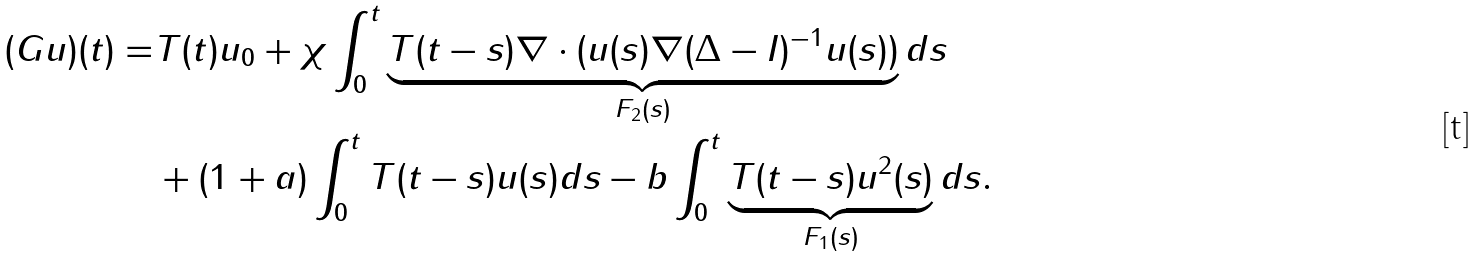Convert formula to latex. <formula><loc_0><loc_0><loc_500><loc_500>( G u ) ( t ) = & T ( t ) u _ { 0 } + \chi \int _ { 0 } ^ { t } \underbrace { T ( t - s ) \nabla \cdot ( u ( s ) \nabla ( \Delta - I ) ^ { - 1 } u ( s ) ) } _ { F _ { 2 } ( s ) } d s \\ & + ( 1 + a ) \int _ { 0 } ^ { t } T ( t - s ) u ( s ) d s - b \int _ { 0 } ^ { t } \underbrace { T ( t - s ) u ^ { 2 } ( s ) } _ { F _ { 1 } ( s ) } d s .</formula> 